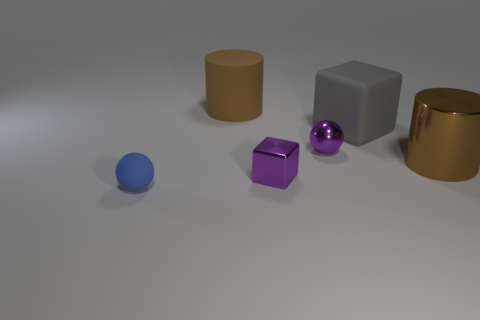There is a large rubber object that is the same color as the metal cylinder; what is its shape?
Your answer should be compact. Cylinder. There is a sphere behind the cylinder that is in front of the matte cube; what is its size?
Your response must be concise. Small. The object that is left of the tiny cube and in front of the big gray thing is made of what material?
Make the answer very short. Rubber. How many other objects are the same size as the purple shiny block?
Ensure brevity in your answer.  2. The large metal cylinder has what color?
Keep it short and to the point. Brown. There is a tiny ball that is to the right of the small rubber sphere; is it the same color as the tiny metal object in front of the brown metallic object?
Give a very brief answer. Yes. The metal block has what size?
Keep it short and to the point. Small. There is a sphere that is behind the small matte ball; what size is it?
Offer a very short reply. Small. There is a small object that is both in front of the tiny shiny sphere and behind the blue matte sphere; what shape is it?
Ensure brevity in your answer.  Cube. How many other things are the same shape as the big gray thing?
Your response must be concise. 1. 